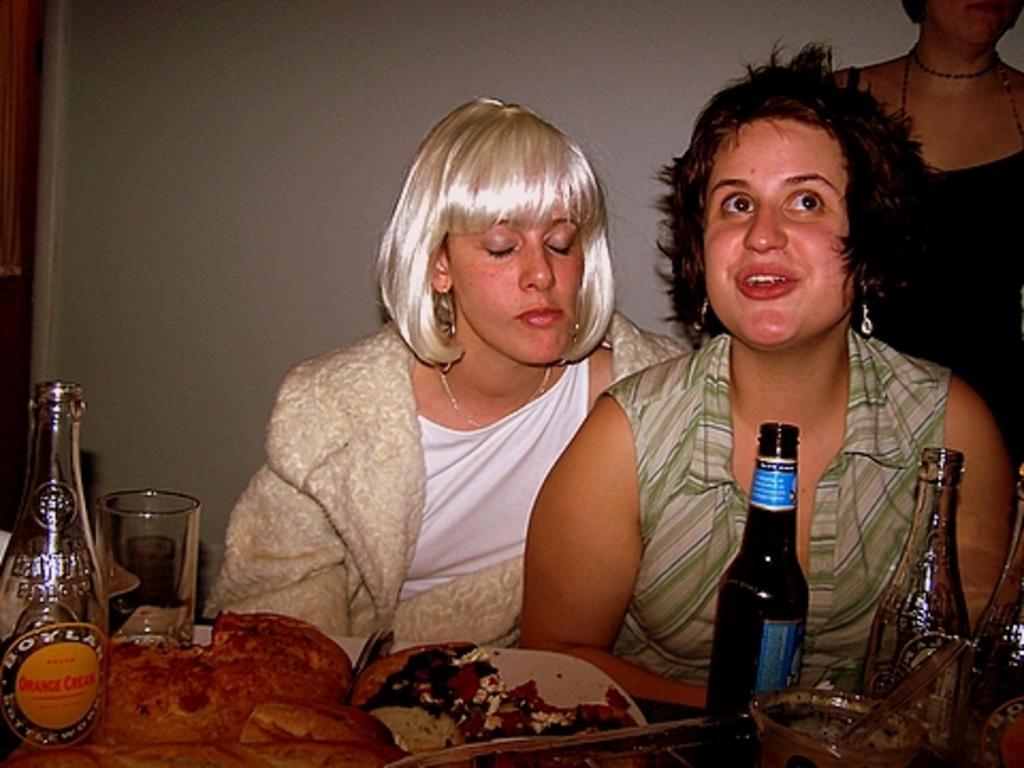In one or two sentences, can you explain what this image depicts? There are two women sitting on the chairs. This is table. On the table there are plates, bottles, glass, and some food. In the background there is a wall. 